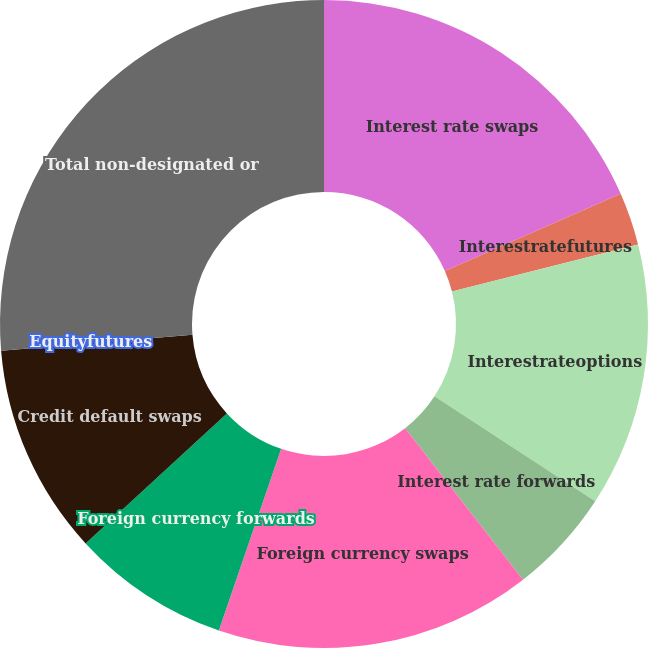Convert chart to OTSL. <chart><loc_0><loc_0><loc_500><loc_500><pie_chart><fcel>Interest rate swaps<fcel>Interestratefutures<fcel>Interestrateoptions<fcel>Interest rate forwards<fcel>Foreign currency swaps<fcel>Foreign currency forwards<fcel>Credit default swaps<fcel>Equityfutures<fcel>Total non-designated or<nl><fcel>18.42%<fcel>2.63%<fcel>13.16%<fcel>5.26%<fcel>15.79%<fcel>7.9%<fcel>10.53%<fcel>0.0%<fcel>26.31%<nl></chart> 